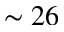Convert formula to latex. <formula><loc_0><loc_0><loc_500><loc_500>\sim 2 6</formula> 